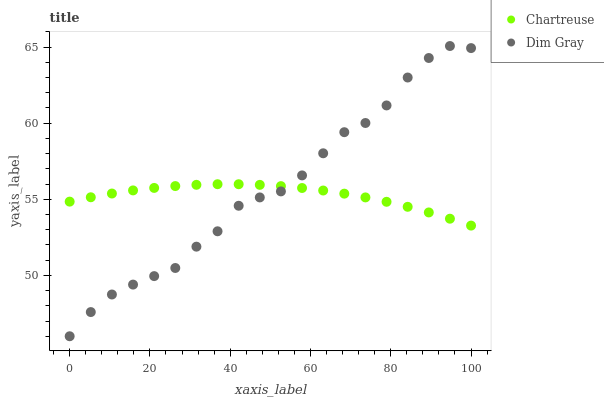Does Chartreuse have the minimum area under the curve?
Answer yes or no. Yes. Does Dim Gray have the maximum area under the curve?
Answer yes or no. Yes. Does Dim Gray have the minimum area under the curve?
Answer yes or no. No. Is Chartreuse the smoothest?
Answer yes or no. Yes. Is Dim Gray the roughest?
Answer yes or no. Yes. Is Dim Gray the smoothest?
Answer yes or no. No. Does Dim Gray have the lowest value?
Answer yes or no. Yes. Does Dim Gray have the highest value?
Answer yes or no. Yes. Does Dim Gray intersect Chartreuse?
Answer yes or no. Yes. Is Dim Gray less than Chartreuse?
Answer yes or no. No. Is Dim Gray greater than Chartreuse?
Answer yes or no. No. 